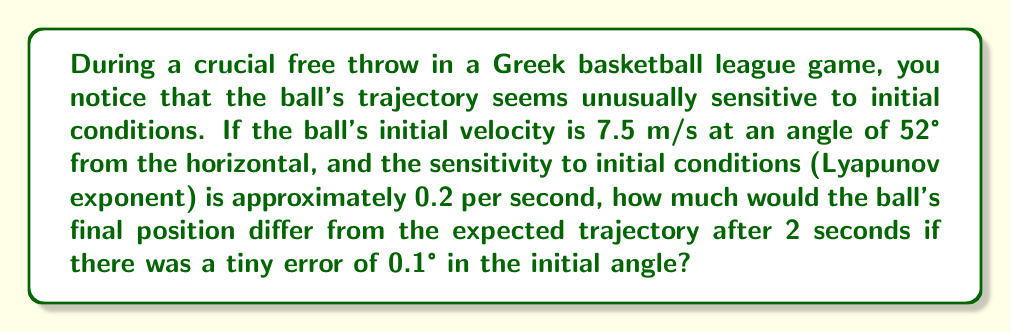What is the answer to this math problem? Let's approach this step-by-step:

1) The Lyapunov exponent (λ) measures the rate at which nearby trajectories diverge. In this case, λ = 0.2 per second.

2) The divergence of trajectories over time is given by the equation:

   $$d(t) = d_0 e^{\lambda t}$$

   Where $d(t)$ is the separation at time $t$, and $d_0$ is the initial separation.

3) We need to calculate $d_0$. This is the initial difference caused by the 0.1° error.

4) The ball's initial velocity vector can be decomposed into horizontal and vertical components:

   $$v_x = v \cos(\theta)$$
   $$v_y = v \sin(\theta)$$

5) For the correct angle (52°):
   $$v_x = 7.5 \cos(52°) \approx 4.62 \text{ m/s}$$
   $$v_y = 7.5 \sin(52°) \approx 5.92 \text{ m/s}$$

6) For the error angle (52.1°):
   $$v_x' = 7.5 \cos(52.1°) \approx 4.61 \text{ m/s}$$
   $$v_y' = 7.5 \sin(52.1°) \approx 5.93 \text{ m/s}$$

7) The initial separation $d_0$ is the magnitude of the difference between these vectors:

   $$d_0 = \sqrt{(4.61 - 4.62)^2 + (5.93 - 5.92)^2} \approx 0.0131 \text{ m}$$

8) Now we can calculate the separation after 2 seconds:

   $$d(2) = 0.0131 e^{0.2 \cdot 2} \approx 0.0195 \text{ m}$$

9) The difference in final position is therefore approximately 0.0195 meters or 1.95 cm.
Answer: 1.95 cm 